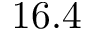Convert formula to latex. <formula><loc_0><loc_0><loc_500><loc_500>1 6 . 4</formula> 